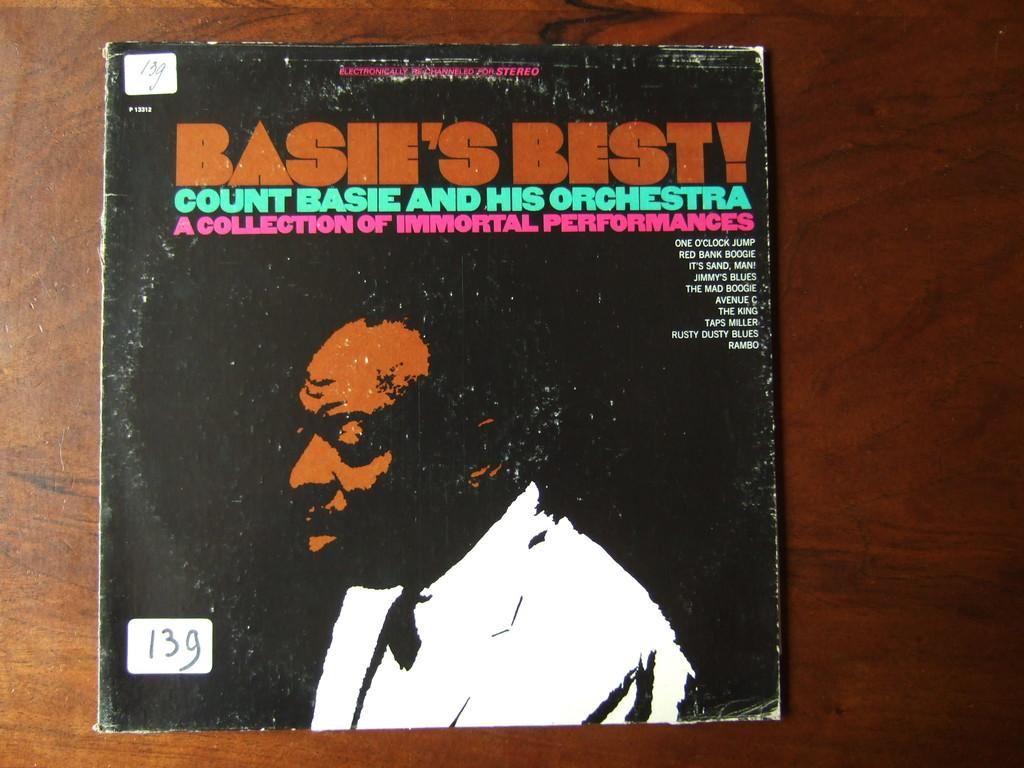Provide a one-sentence caption for the provided image. Basie's best count basie and his orchestra collection. 